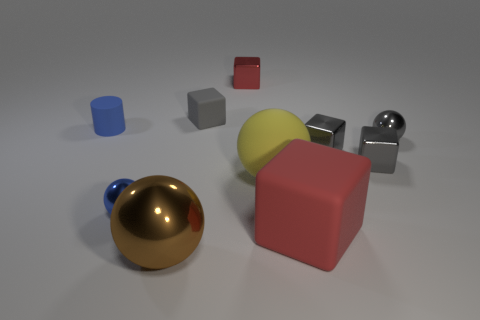Describe the arrangement of objects. Does it follow a specific pattern? The objects are arranged in a somewhat scattered formation, but there's a semblance of balance with the spheres spread out on one side and the cubes on the other. There's no strict pattern or symmetry; it looks more like a casual layout with a mix of shapes and colors. 